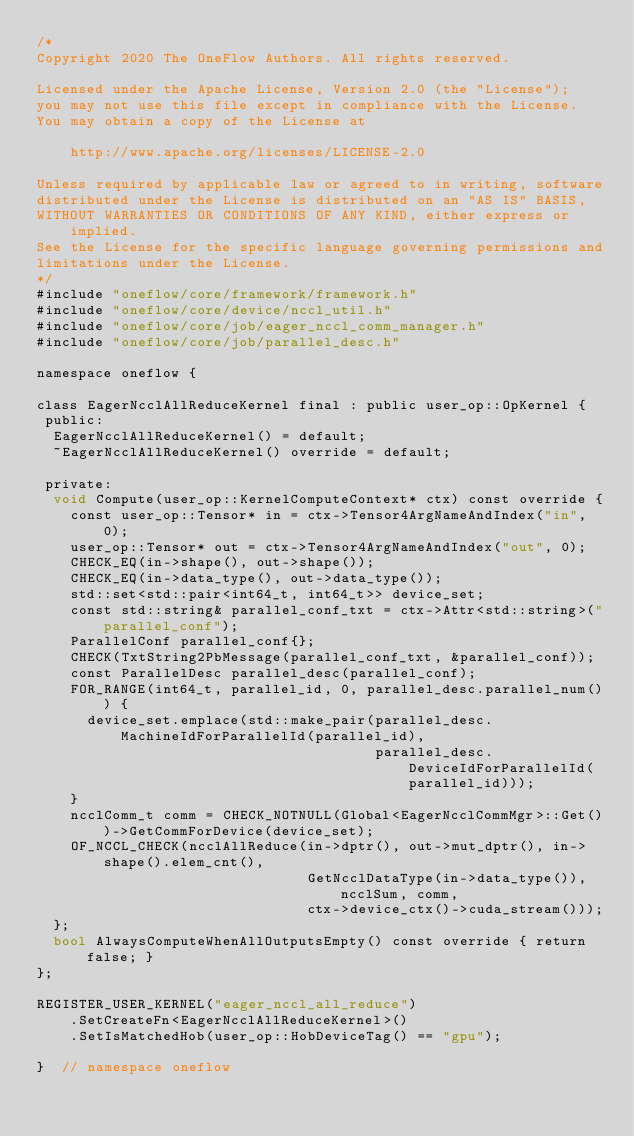Convert code to text. <code><loc_0><loc_0><loc_500><loc_500><_Cuda_>/*
Copyright 2020 The OneFlow Authors. All rights reserved.

Licensed under the Apache License, Version 2.0 (the "License");
you may not use this file except in compliance with the License.
You may obtain a copy of the License at

    http://www.apache.org/licenses/LICENSE-2.0

Unless required by applicable law or agreed to in writing, software
distributed under the License is distributed on an "AS IS" BASIS,
WITHOUT WARRANTIES OR CONDITIONS OF ANY KIND, either express or implied.
See the License for the specific language governing permissions and
limitations under the License.
*/
#include "oneflow/core/framework/framework.h"
#include "oneflow/core/device/nccl_util.h"
#include "oneflow/core/job/eager_nccl_comm_manager.h"
#include "oneflow/core/job/parallel_desc.h"

namespace oneflow {

class EagerNcclAllReduceKernel final : public user_op::OpKernel {
 public:
  EagerNcclAllReduceKernel() = default;
  ~EagerNcclAllReduceKernel() override = default;

 private:
  void Compute(user_op::KernelComputeContext* ctx) const override {
    const user_op::Tensor* in = ctx->Tensor4ArgNameAndIndex("in", 0);
    user_op::Tensor* out = ctx->Tensor4ArgNameAndIndex("out", 0);
    CHECK_EQ(in->shape(), out->shape());
    CHECK_EQ(in->data_type(), out->data_type());
    std::set<std::pair<int64_t, int64_t>> device_set;
    const std::string& parallel_conf_txt = ctx->Attr<std::string>("parallel_conf");
    ParallelConf parallel_conf{};
    CHECK(TxtString2PbMessage(parallel_conf_txt, &parallel_conf));
    const ParallelDesc parallel_desc(parallel_conf);
    FOR_RANGE(int64_t, parallel_id, 0, parallel_desc.parallel_num()) {
      device_set.emplace(std::make_pair(parallel_desc.MachineIdForParallelId(parallel_id),
                                        parallel_desc.DeviceIdForParallelId(parallel_id)));
    }
    ncclComm_t comm = CHECK_NOTNULL(Global<EagerNcclCommMgr>::Get())->GetCommForDevice(device_set);
    OF_NCCL_CHECK(ncclAllReduce(in->dptr(), out->mut_dptr(), in->shape().elem_cnt(),
                                GetNcclDataType(in->data_type()), ncclSum, comm,
                                ctx->device_ctx()->cuda_stream()));
  };
  bool AlwaysComputeWhenAllOutputsEmpty() const override { return false; }
};

REGISTER_USER_KERNEL("eager_nccl_all_reduce")
    .SetCreateFn<EagerNcclAllReduceKernel>()
    .SetIsMatchedHob(user_op::HobDeviceTag() == "gpu");

}  // namespace oneflow
</code> 